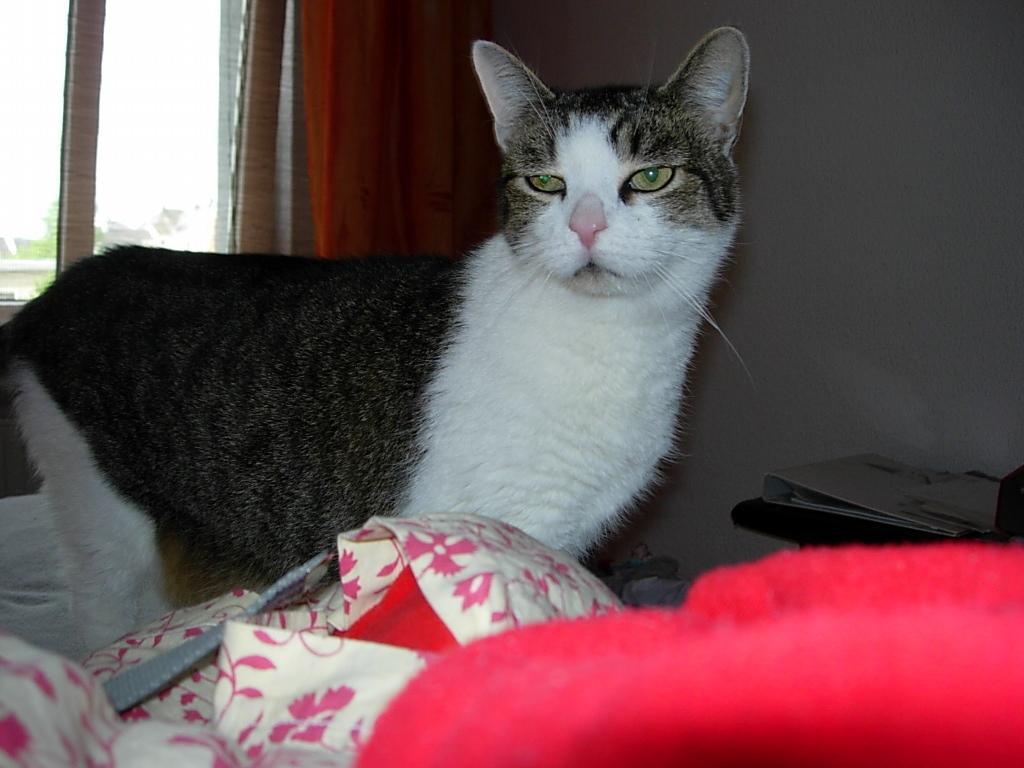Describe this image in one or two sentences. In this image, there is a cat on the bed. There is a table on the right side of the image contains a file. There is a window in the top left of the image. 